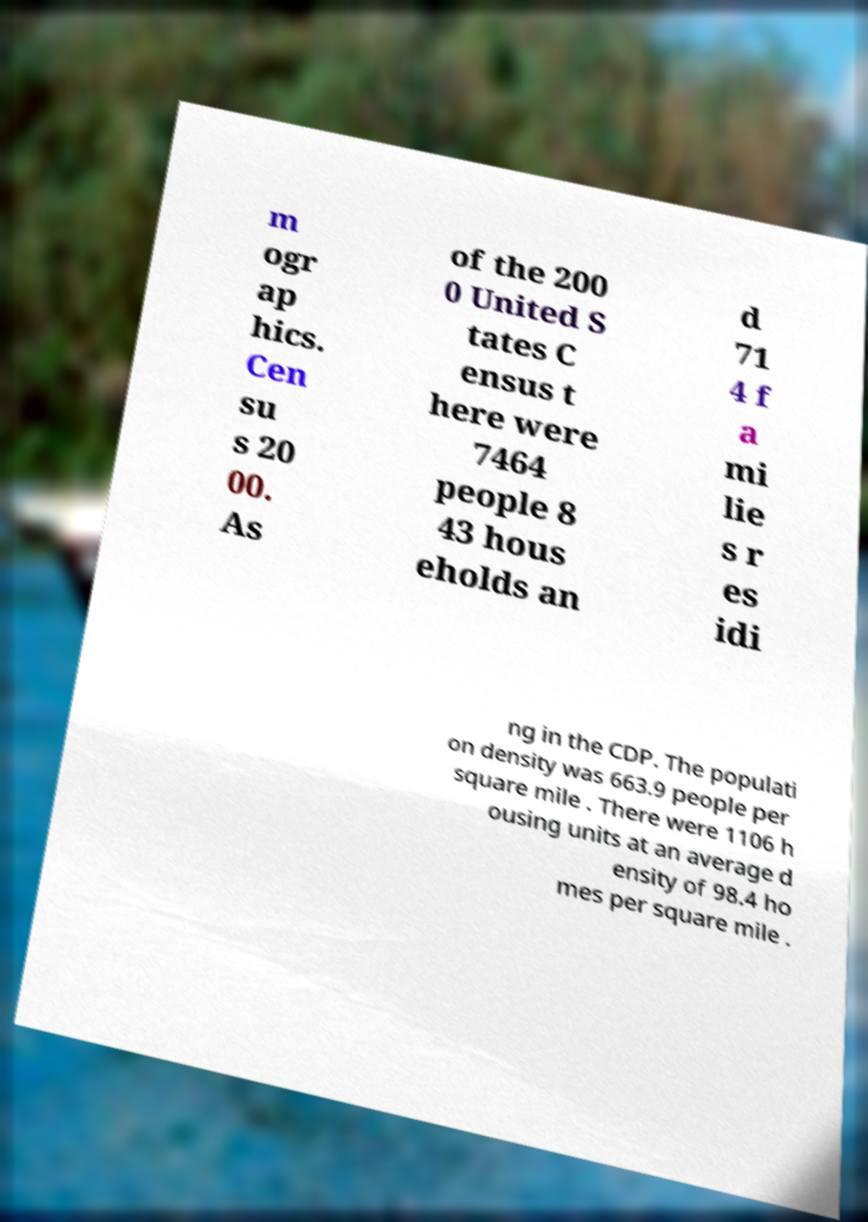Please identify and transcribe the text found in this image. m ogr ap hics. Cen su s 20 00. As of the 200 0 United S tates C ensus t here were 7464 people 8 43 hous eholds an d 71 4 f a mi lie s r es idi ng in the CDP. The populati on density was 663.9 people per square mile . There were 1106 h ousing units at an average d ensity of 98.4 ho mes per square mile . 